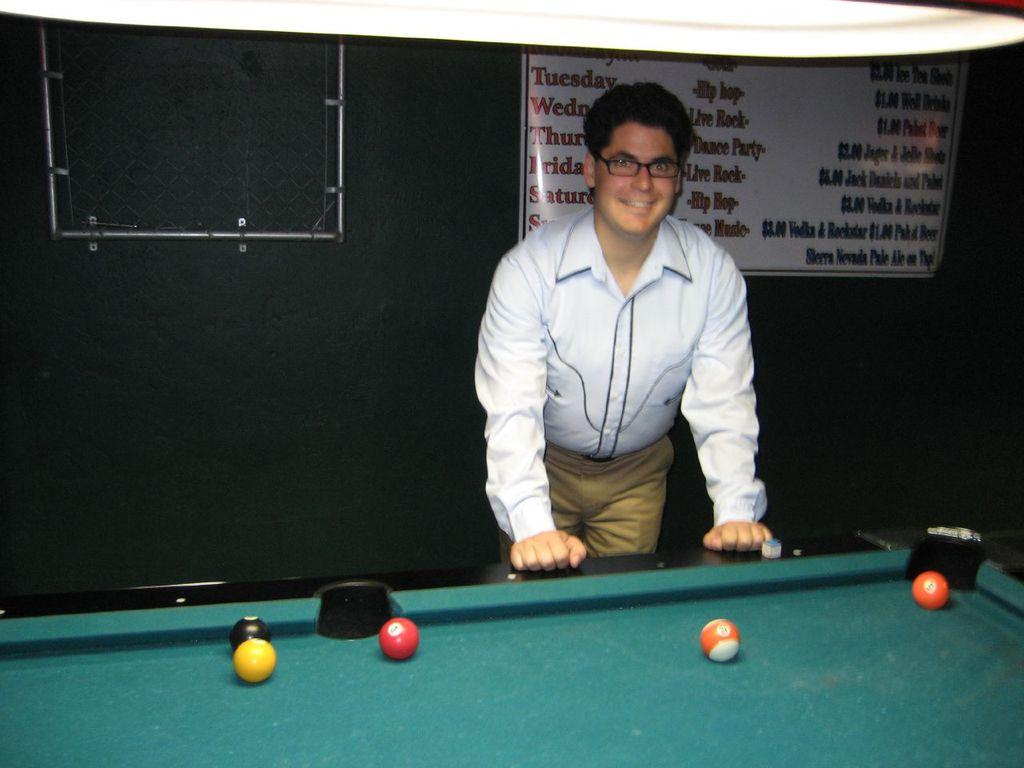What is the main subject of the image? There is a man standing in the image. What else can be seen in the image besides the man? There is a banner and a billiards board in the image. How many marks are visible on the billiards board in the image? There is no mention of marks on the billiards board in the provided facts, so it cannot be determined from the image. 